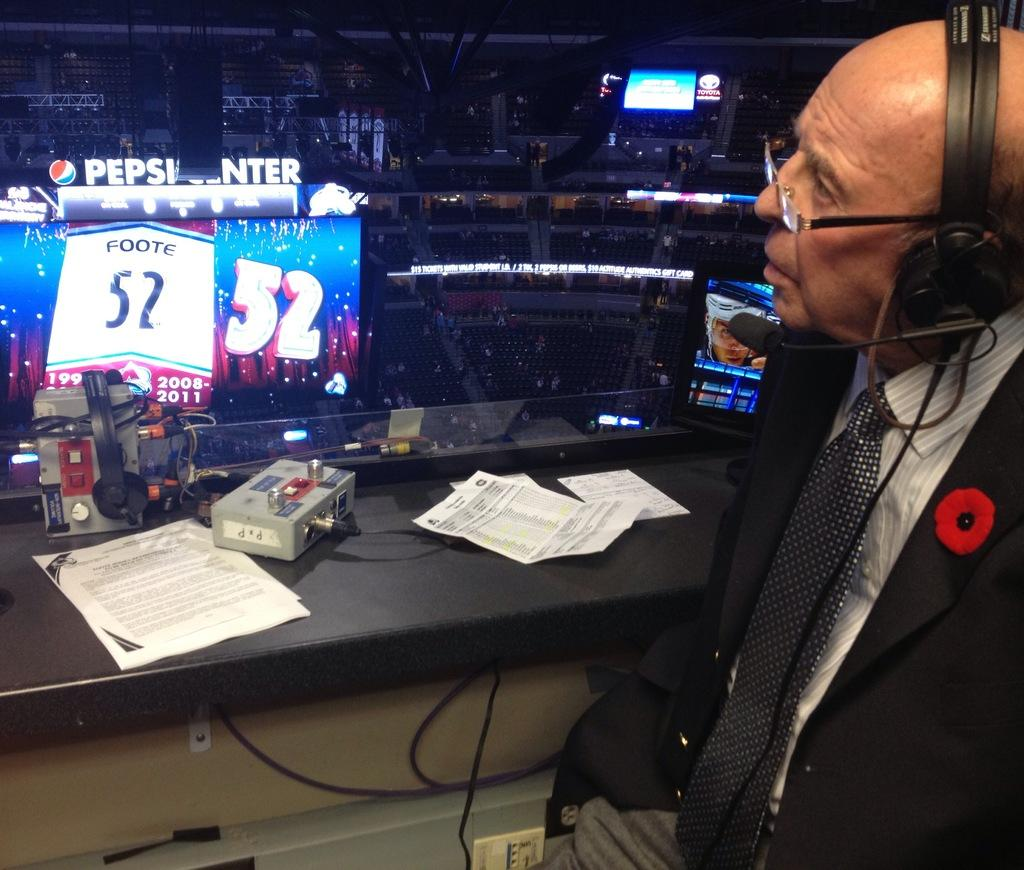<image>
Share a concise interpretation of the image provided. A broadcaster sits in a booth opposite a Pepsi advertisement. 